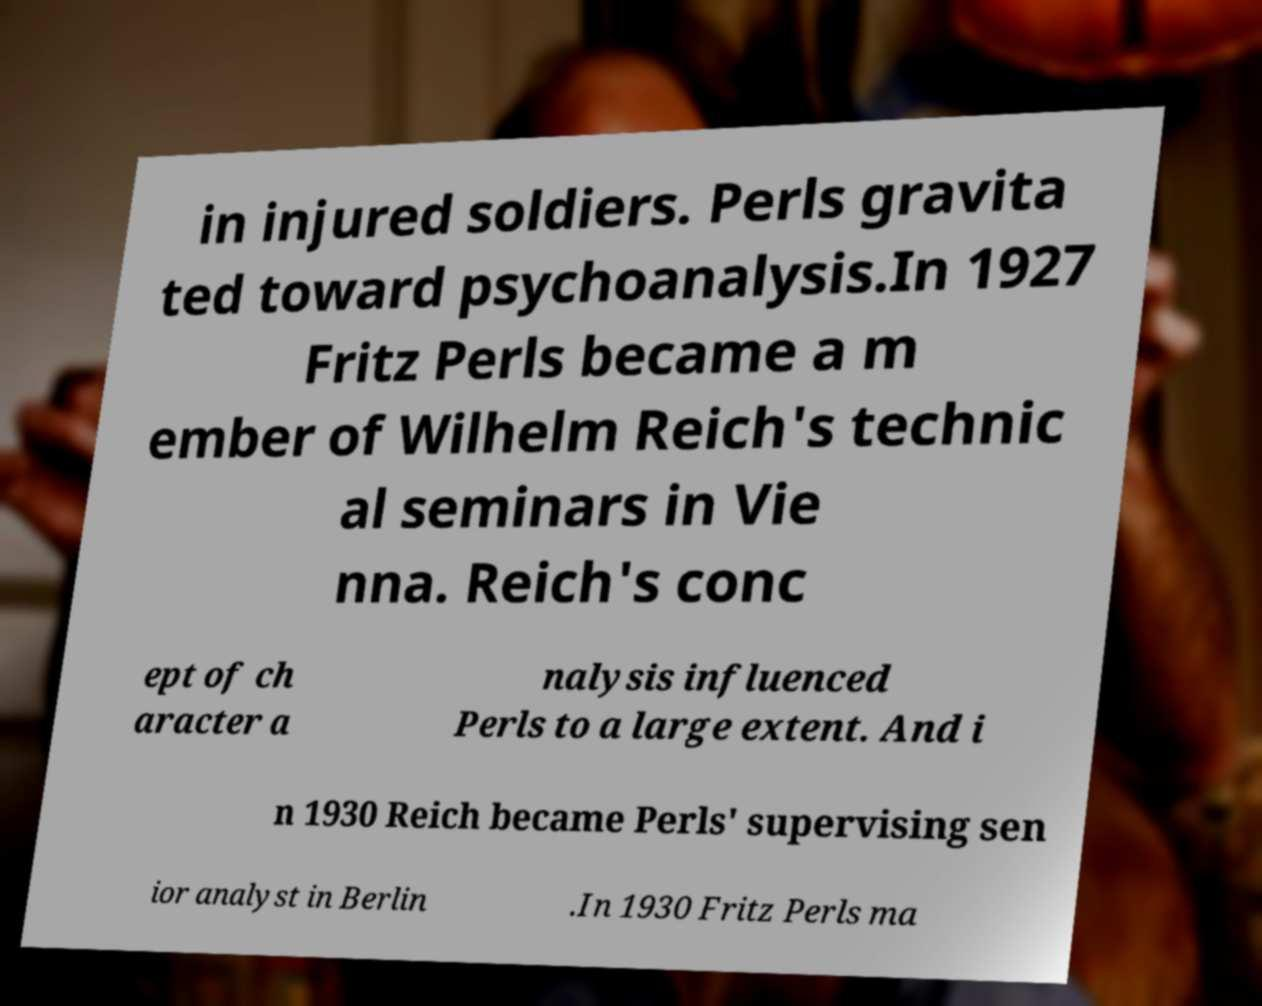Could you assist in decoding the text presented in this image and type it out clearly? in injured soldiers. Perls gravita ted toward psychoanalysis.In 1927 Fritz Perls became a m ember of Wilhelm Reich's technic al seminars in Vie nna. Reich's conc ept of ch aracter a nalysis influenced Perls to a large extent. And i n 1930 Reich became Perls' supervising sen ior analyst in Berlin .In 1930 Fritz Perls ma 